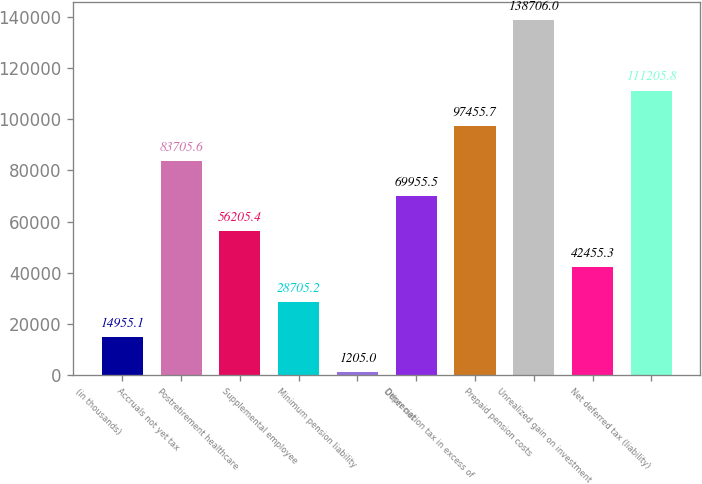Convert chart. <chart><loc_0><loc_0><loc_500><loc_500><bar_chart><fcel>(in thousands)<fcel>Accruals not yet tax<fcel>Postretirement healthcare<fcel>Supplemental employee<fcel>Minimum pension liability<fcel>Other net<fcel>Depreciation tax in excess of<fcel>Prepaid pension costs<fcel>Unrealized gain on investment<fcel>Net deferred tax (liability)<nl><fcel>14955.1<fcel>83705.6<fcel>56205.4<fcel>28705.2<fcel>1205<fcel>69955.5<fcel>97455.7<fcel>138706<fcel>42455.3<fcel>111206<nl></chart> 